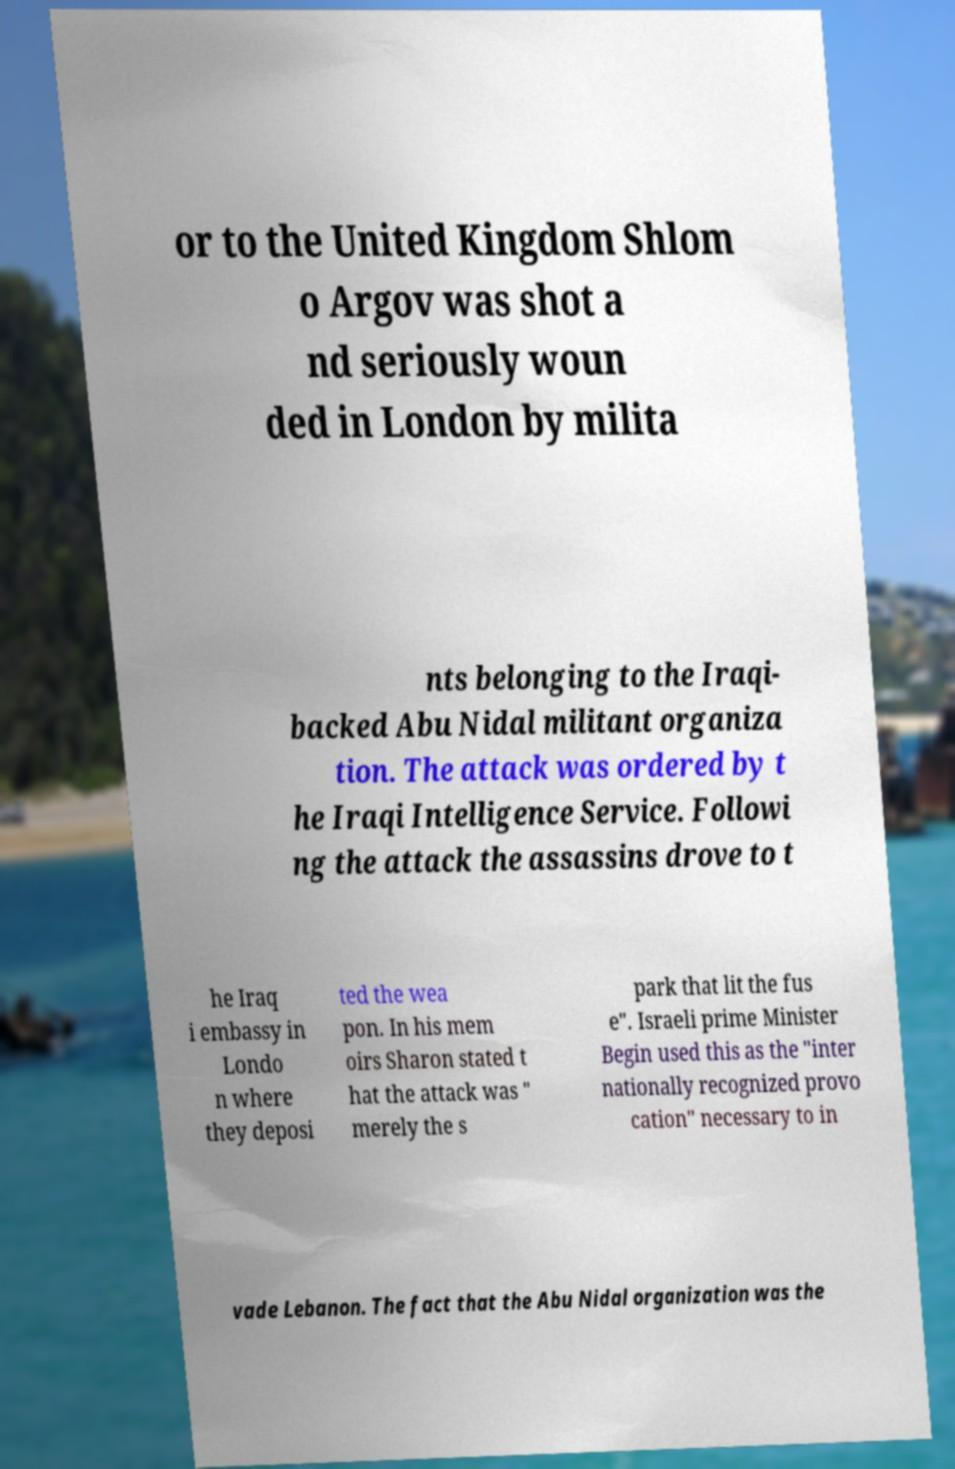Can you accurately transcribe the text from the provided image for me? or to the United Kingdom Shlom o Argov was shot a nd seriously woun ded in London by milita nts belonging to the Iraqi- backed Abu Nidal militant organiza tion. The attack was ordered by t he Iraqi Intelligence Service. Followi ng the attack the assassins drove to t he Iraq i embassy in Londo n where they deposi ted the wea pon. In his mem oirs Sharon stated t hat the attack was " merely the s park that lit the fus e". Israeli prime Minister Begin used this as the "inter nationally recognized provo cation" necessary to in vade Lebanon. The fact that the Abu Nidal organization was the 